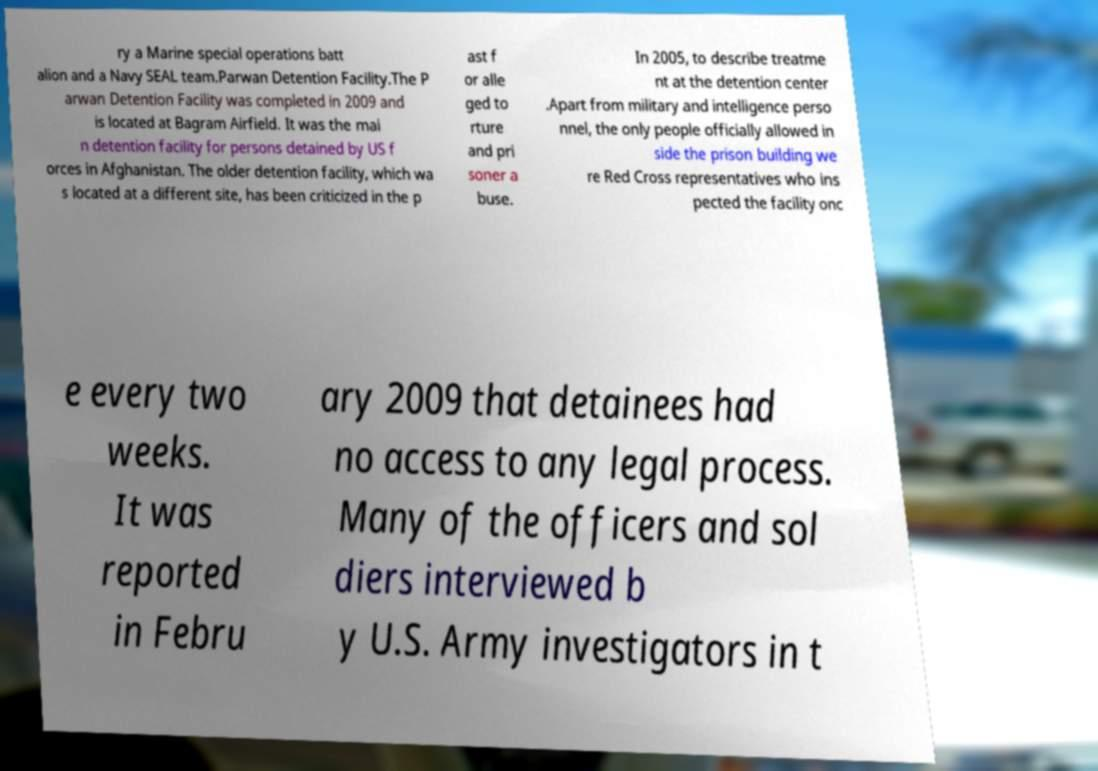Could you extract and type out the text from this image? ry a Marine special operations batt alion and a Navy SEAL team.Parwan Detention Facility.The P arwan Detention Facility was completed in 2009 and is located at Bagram Airfield. It was the mai n detention facility for persons detained by US f orces in Afghanistan. The older detention facility, which wa s located at a different site, has been criticized in the p ast f or alle ged to rture and pri soner a buse. In 2005, to describe treatme nt at the detention center .Apart from military and intelligence perso nnel, the only people officially allowed in side the prison building we re Red Cross representatives who ins pected the facility onc e every two weeks. It was reported in Febru ary 2009 that detainees had no access to any legal process. Many of the officers and sol diers interviewed b y U.S. Army investigators in t 